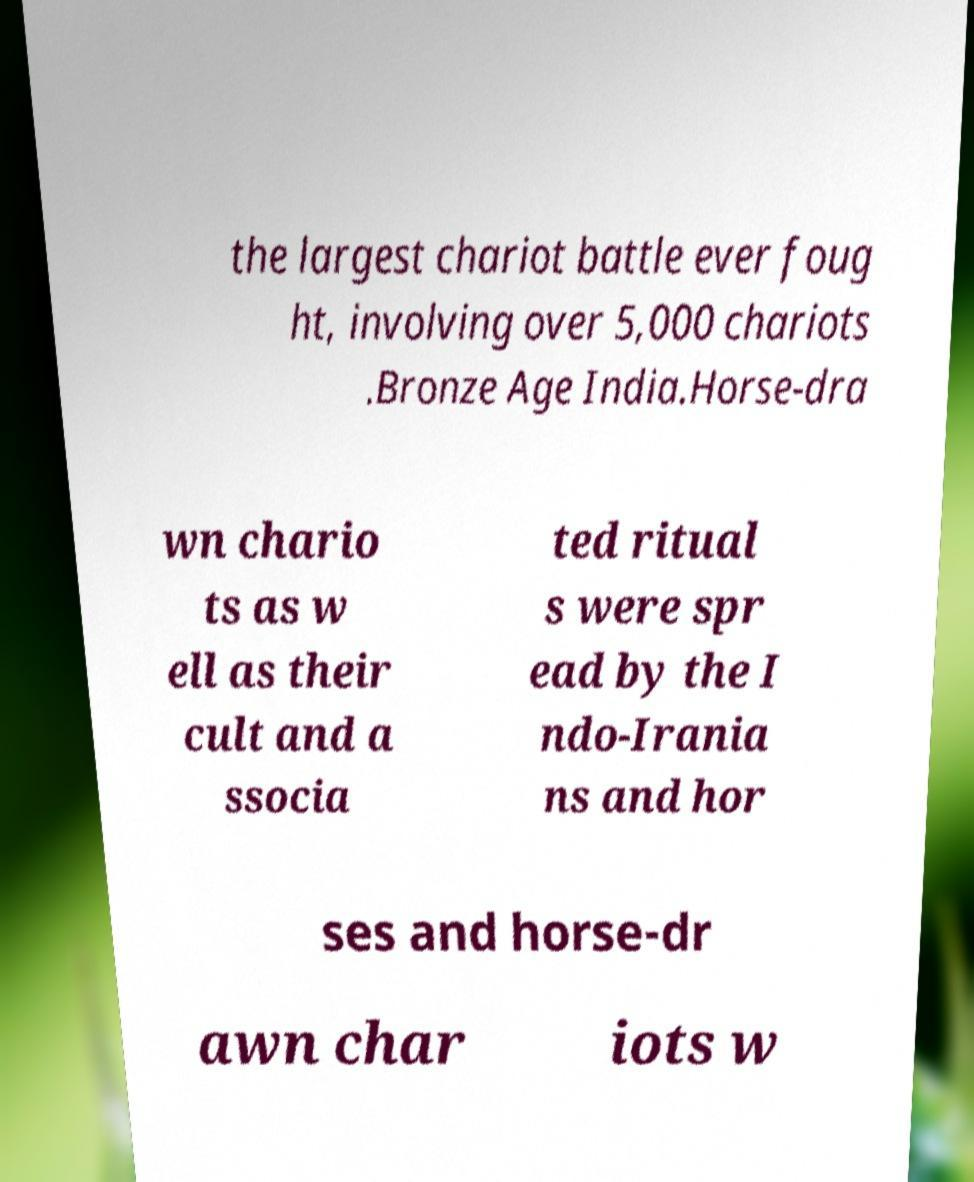Could you assist in decoding the text presented in this image and type it out clearly? the largest chariot battle ever foug ht, involving over 5,000 chariots .Bronze Age India.Horse-dra wn chario ts as w ell as their cult and a ssocia ted ritual s were spr ead by the I ndo-Irania ns and hor ses and horse-dr awn char iots w 